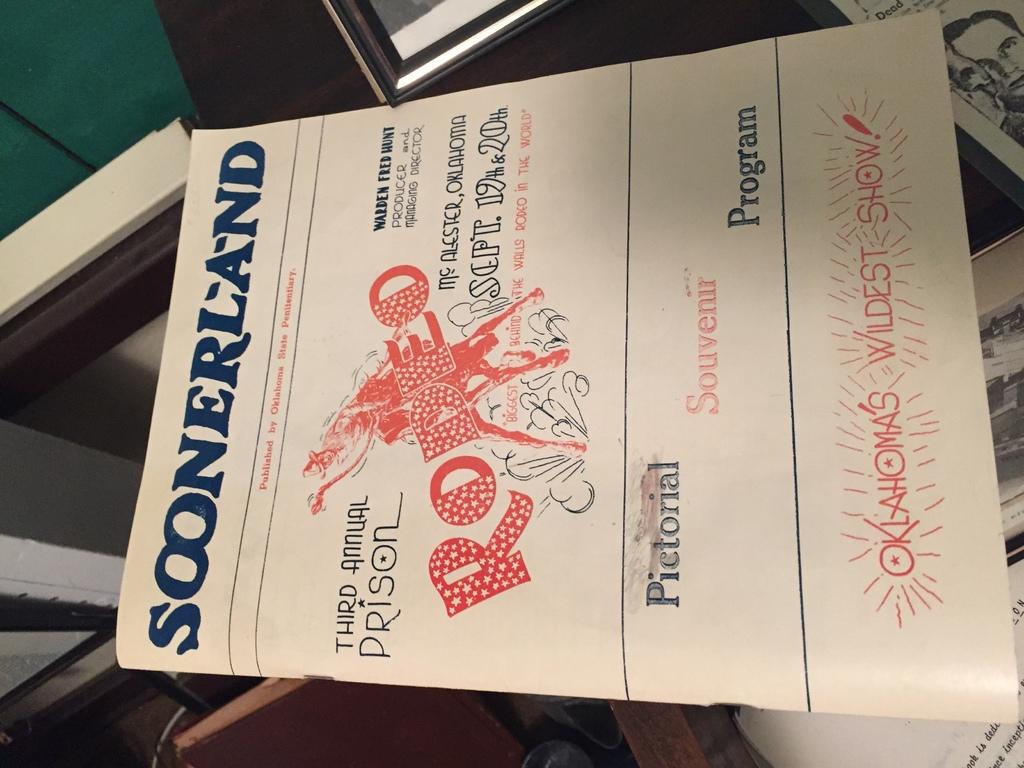How many times has this rodeo occurred?
Offer a terse response. 3. 